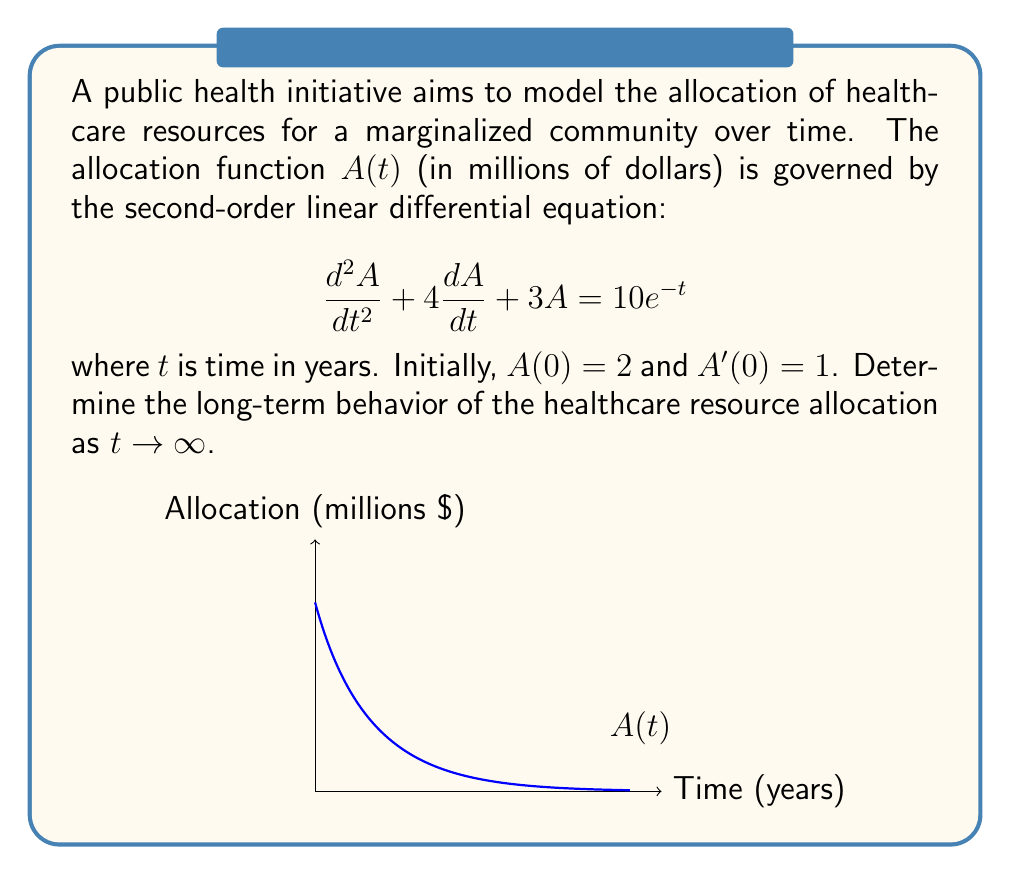Teach me how to tackle this problem. To solve this problem, we'll follow these steps:

1) The general solution to this equation is the sum of the complementary function and the particular integral:

   $A(t) = A_c(t) + A_p(t)$

2) The complementary function $A_c(t)$ is the solution to the homogeneous equation:
   
   $$\frac{d^2A}{dt^2} + 4\frac{dA}{dt} + 3A = 0$$

   The characteristic equation is $r^2 + 4r + 3 = 0$, with roots $r_1 = -1$ and $r_2 = -3$.
   
   Thus, $A_c(t) = c_1e^{-t} + c_2e^{-3t}$

3) For the particular integral $A_p(t)$, we guess a solution of the form $A_p(t) = ke^{-t}$:

   Substituting this into the original equation:
   
   $$(k)e^{-t} + 4(-k)e^{-t} + 3ke^{-t} = 10e^{-t}$$
   
   $$(1 - 4 + 3)ke^{-t} = 10e^{-t}$$
   
   $$k = \frac{10}{0} = \frac{2}{3}$$

   So, $A_p(t) = \frac{2}{3}e^{-t}$

4) The general solution is:

   $$A(t) = c_1e^{-t} + c_2e^{-3t} + \frac{2}{3}e^{-t}$$

5) Using the initial conditions:

   $A(0) = 2$: $c_1 + c_2 + \frac{2}{3} = 2$
   
   $A'(0) = 1$: $-c_1 - 3c_2 - \frac{2}{3} = 1$

   Solving these equations:
   $c_1 = 2$ and $c_2 = \frac{1}{3}$

6) Therefore, the complete solution is:

   $$A(t) = 2e^{-t} + \frac{1}{3}e^{-3t} + \frac{2}{3}e^{-t} = \frac{8}{3}e^{-t} + \frac{1}{3}e^{-3t}$$

7) To determine the long-term behavior, we take the limit as $t \to \infty$:

   $$\lim_{t \to \infty} A(t) = \lim_{t \to \infty} (\frac{8}{3}e^{-t} + \frac{1}{3}e^{-3t}) = 0 + 0 = 0$$

Thus, the healthcare resource allocation approaches zero in the long term.
Answer: $\lim_{t \to \infty} A(t) = 0$ 